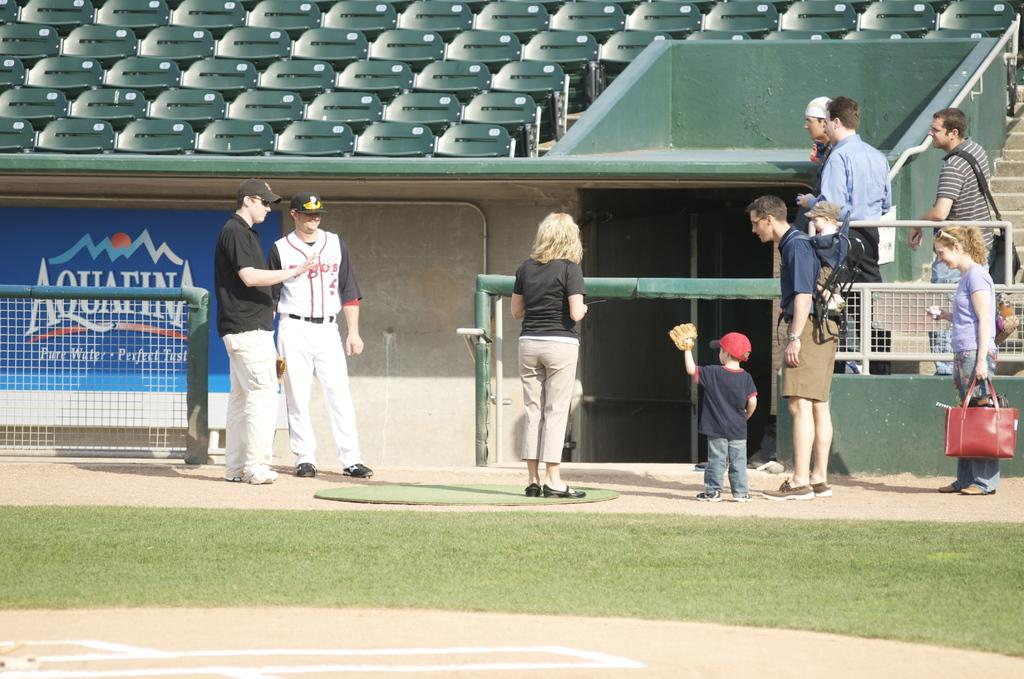<image>
Create a compact narrative representing the image presented. A player and his coach converse near a dugout with a banner by Aquafina. 